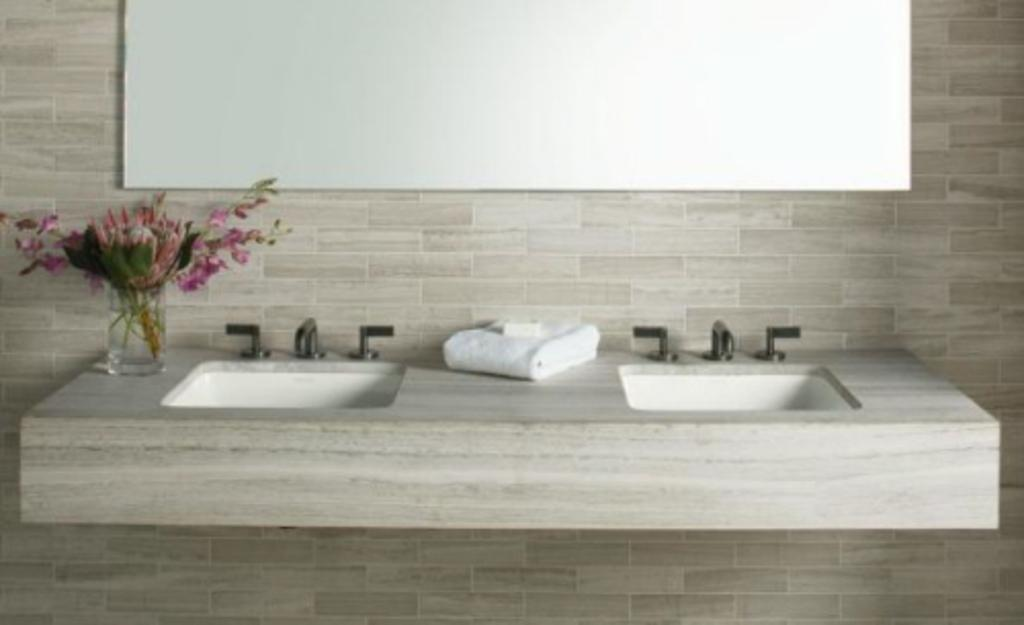What objects are located in the foreground of the picture? There are taps, sinks, a towel, and a flower vase in the foreground of the picture. What is the background of the picture made of? The background of the picture is made of a wall. Can you describe the towel in the foreground? The towel is located near the sinks and taps. What type of apparel is being worn by the heart in the picture? There is no heart or apparel present in the picture. 